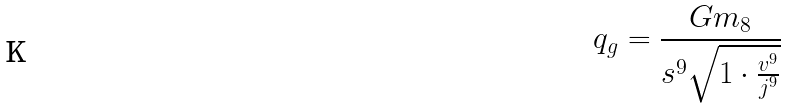Convert formula to latex. <formula><loc_0><loc_0><loc_500><loc_500>q _ { g } = \frac { G m _ { 8 } } { s ^ { 9 } \sqrt { 1 \cdot \frac { v ^ { 9 } } { j ^ { 9 } } } }</formula> 